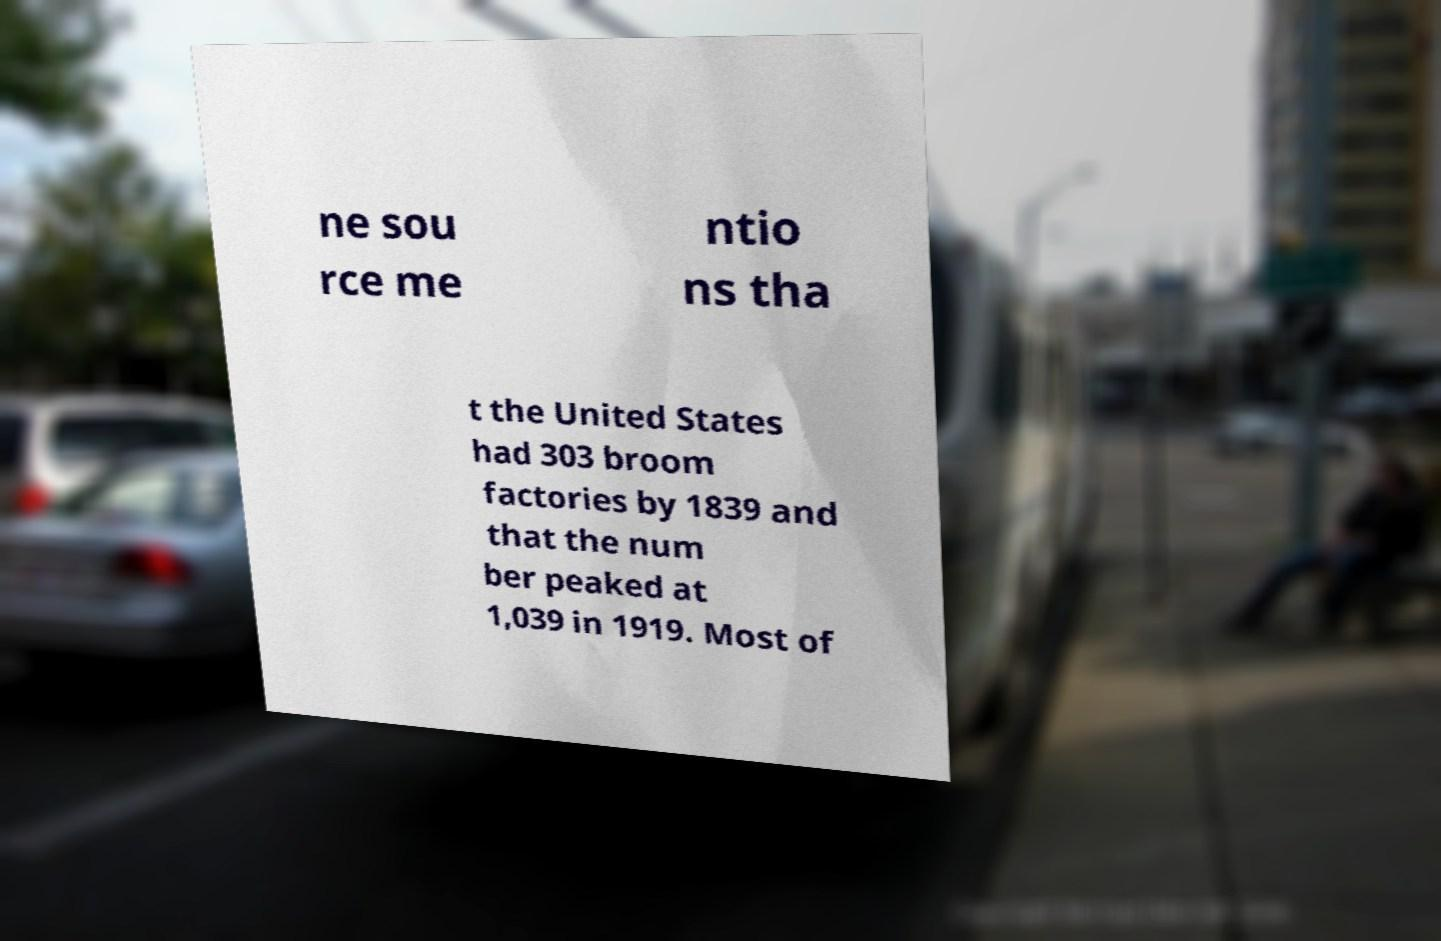Could you assist in decoding the text presented in this image and type it out clearly? ne sou rce me ntio ns tha t the United States had 303 broom factories by 1839 and that the num ber peaked at 1,039 in 1919. Most of 